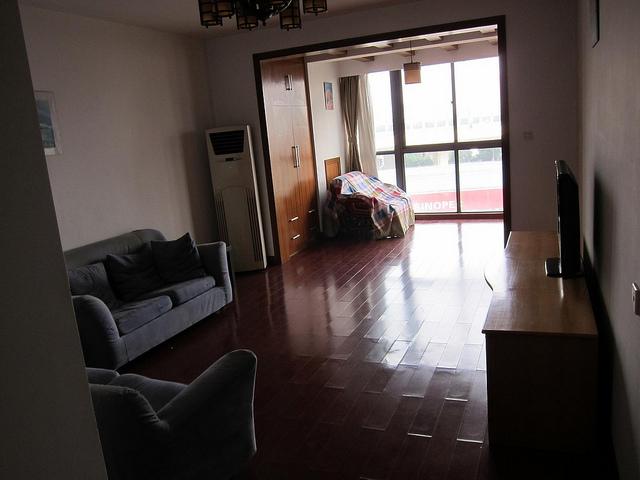Is there a video game console in the picture?
Quick response, please. No. Does this room have natural light?
Write a very short answer. Yes. Is the TV a flat screen?
Answer briefly. Yes. How many TVs are visible?
Concise answer only. 1. The floor clean?
Concise answer only. Yes. Is this room well appointed?
Give a very brief answer. Yes. What is in the casing?
Answer briefly. Couch. Are the patio doors open?
Concise answer only. No. Is there a couch?
Write a very short answer. Yes. What is this room?
Quick response, please. Living room. What room is this?
Write a very short answer. Living room. What room is shown?
Be succinct. Living room. 